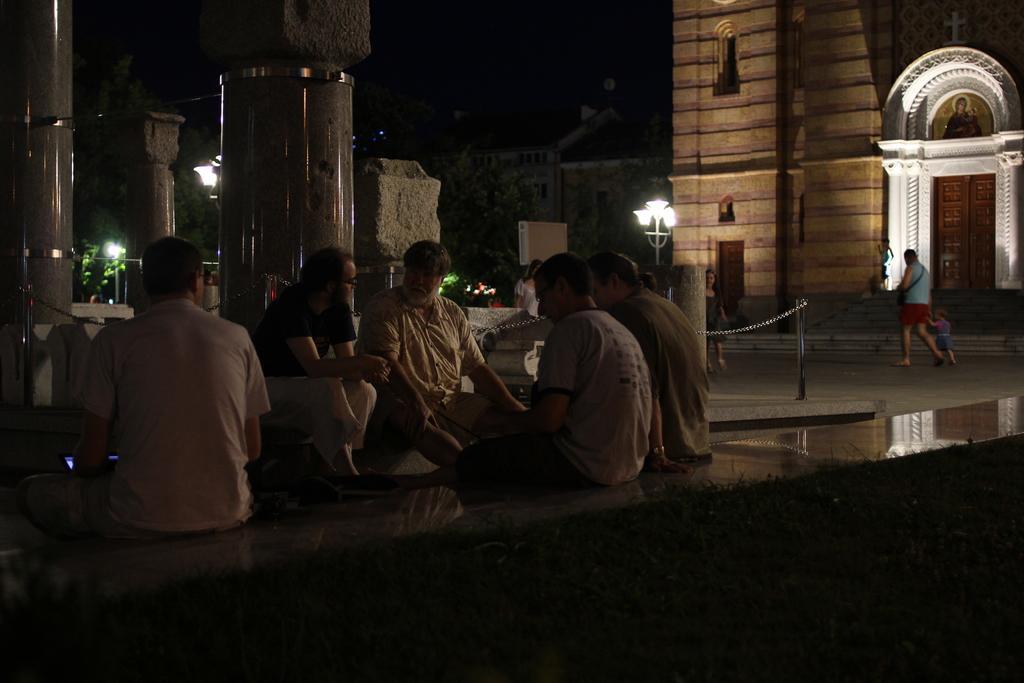Can you describe this image briefly? In this picture I can see a group of people are sitting in the middle. In the background there are lights and buildings. 